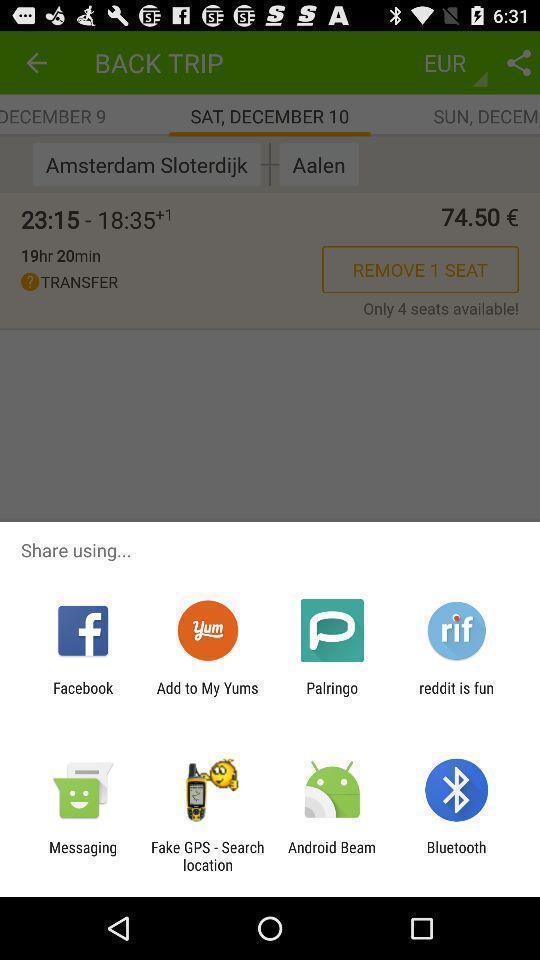Explain the elements present in this screenshot. Pop-up showing different sharing options. 